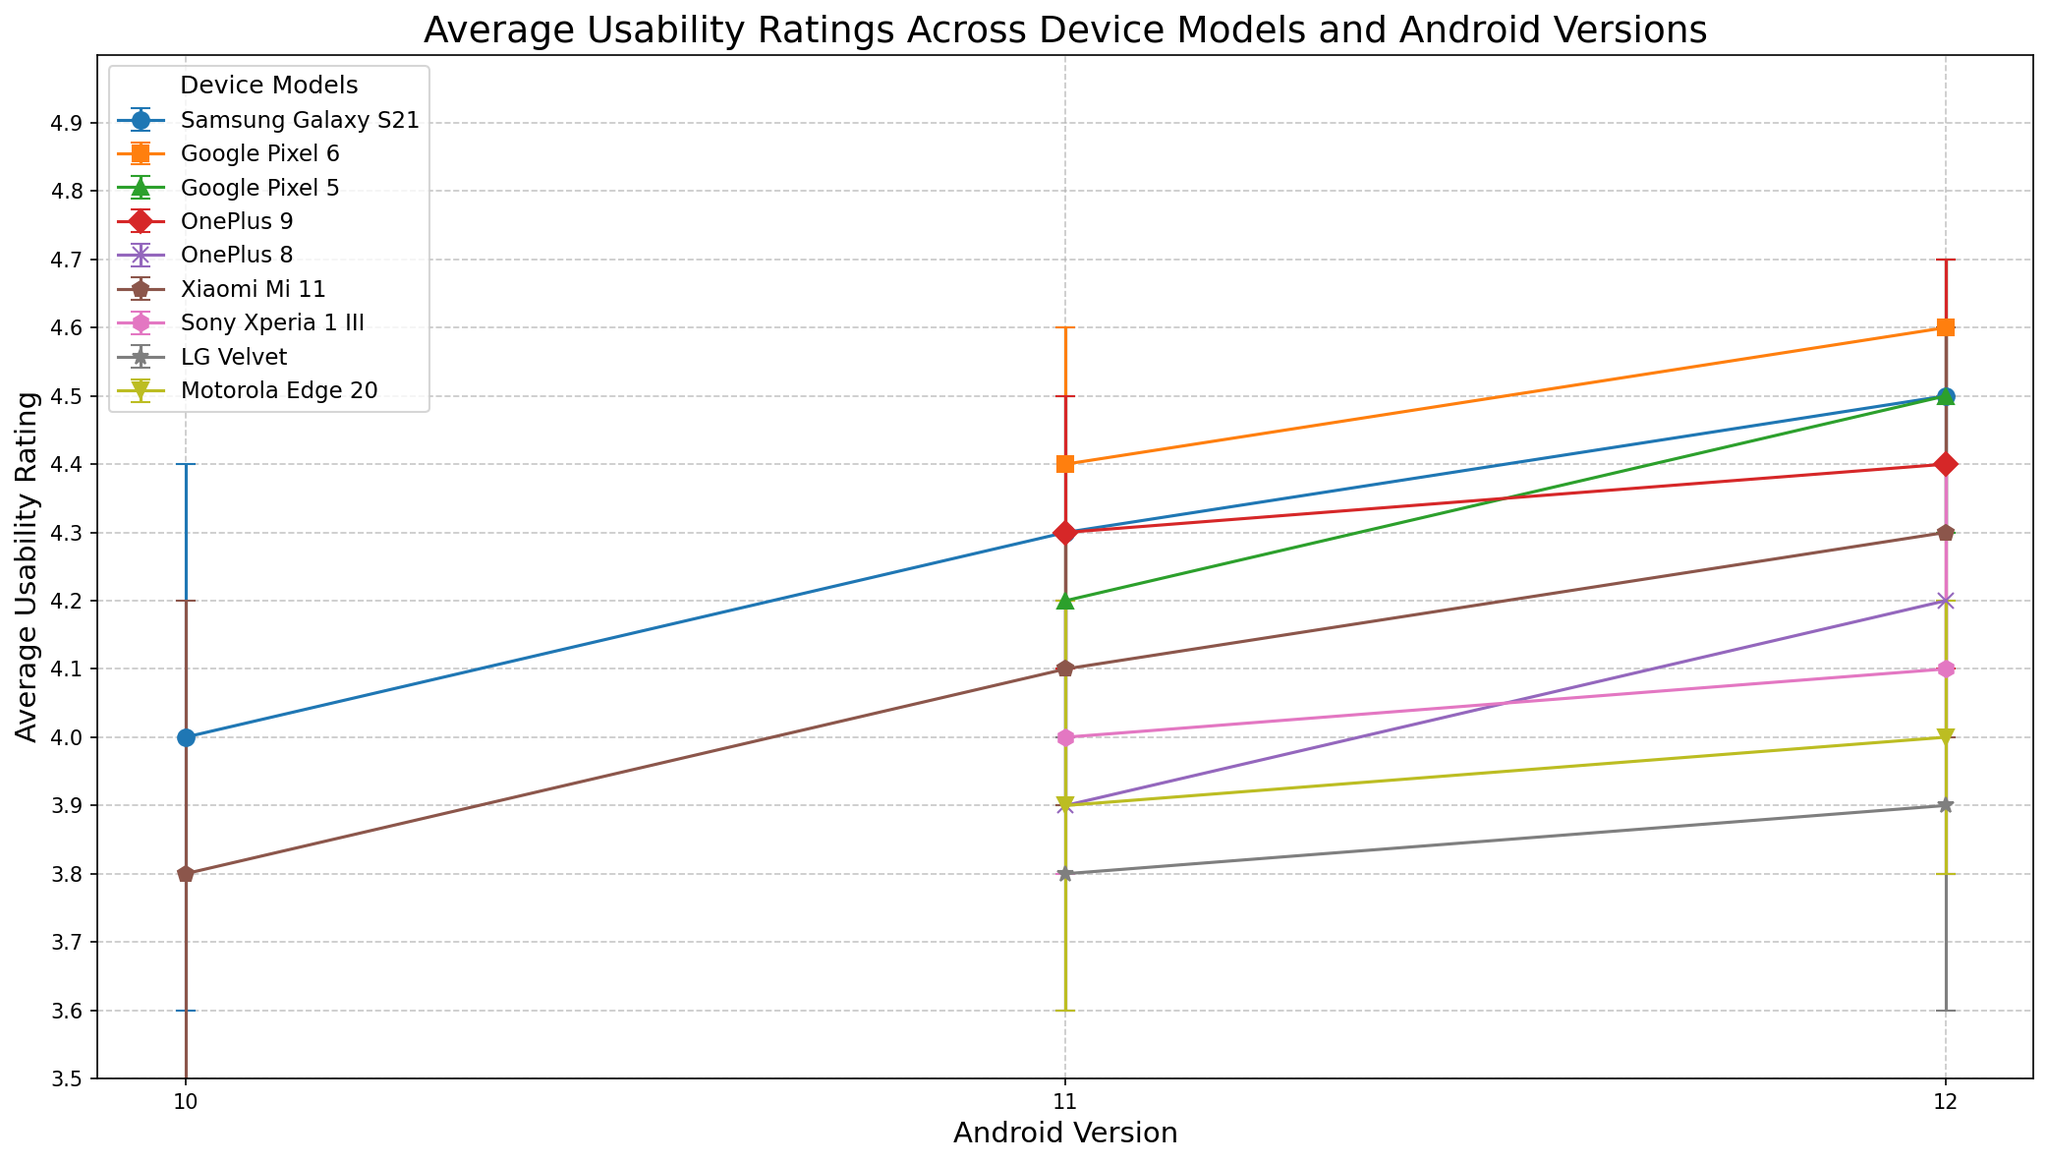Which device model has the highest average usability rating for Android version 12? To determine this, look at the ratings on the x-axis corresponding to Android version 12. Compare the height of the points along with the error margins. Google Pixel 6 has the highest rating (4.6).
Answer: Google Pixel 6 Which device model shows the largest improvement in average usability rating from Android version 10 to 12? Calculate the difference in usability ratings between Android version 10 and Android version 12 for each model. Samsung Galaxy S21 shows the most significant improvement, going from 4.0 to 4.5.
Answer: Samsung Galaxy S21 Which device model has the smallest error margin for Android version 12? Examine the error bars on the points corresponding to Android version 12. Google Pixel 6 has the smallest error margin (0.1).
Answer: Google Pixel 6 How does the usability rating of Google Pixel 5 change between Android versions 11 and 12? Check the points for Google Pixel 5 at Android versions 11 and 12. The rating rises from 4.2 to 4.5, indicating an improvement of 0.3.
Answer: It increases by 0.3 Among Samsung Galaxy S21, Google Pixel 6, and OnePlus 8 on Android version 11, which model has the highest average usability rating? Locate each of these models on the x-axis for Android version 11. Compare their usability ratings: Samsung Galaxy S21 (4.3), Google Pixel 6 (4.4), and OnePlus 8 (3.9). Google Pixel 6 has the highest rating.
Answer: Google Pixel 6 What is the range of usability ratings for all the device models for Android version 12? Find the minimum and maximum rating points for Android version 12. The minimum rating is for LG Velvet (3.9), and the maximum is for Google Pixel 6 (4.6). The range is 4.6 - 3.9 = 0.7.
Answer: 0.7 Which device model and Android version combination has the highest error margin? Identify the point with the longest error bar across all combinations. OnePlus 8 with Android version 12 has the highest error margin (0.4).
Answer: OnePlus 8, Android version 12 For Google Pixel 6, what's the average of the usability ratings for Android versions 11 and 12? Sum the ratings for Google Pixel 6 for versions 11 (4.4) and 12 (4.6), then divide by 2. (4.4 + 4.6) / 2 = 4.5.
Answer: 4.5 